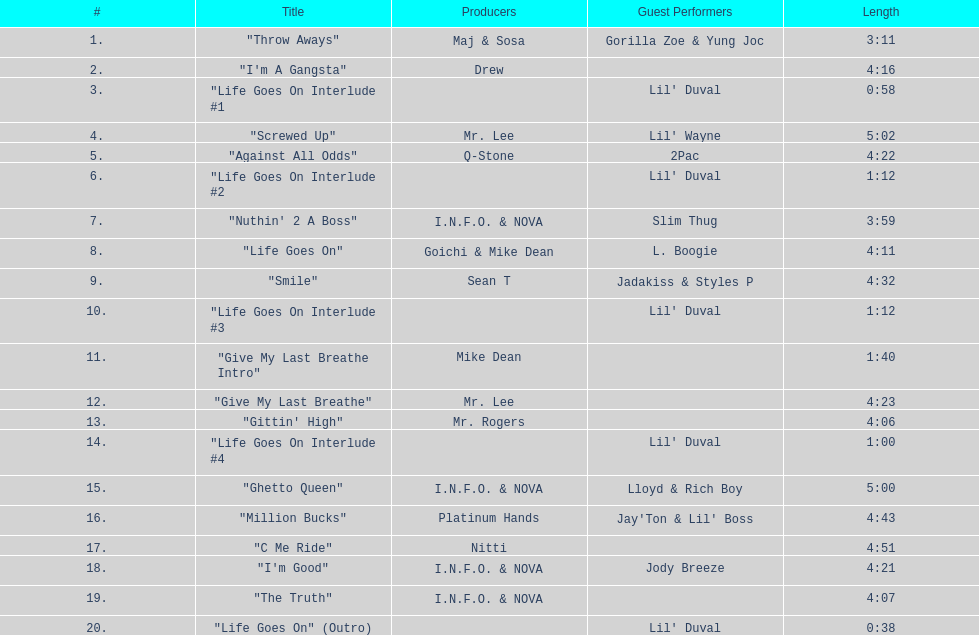Can you identify the consecutive tracks on this album that share the same producer(s)? "I'm Good", "The Truth". 